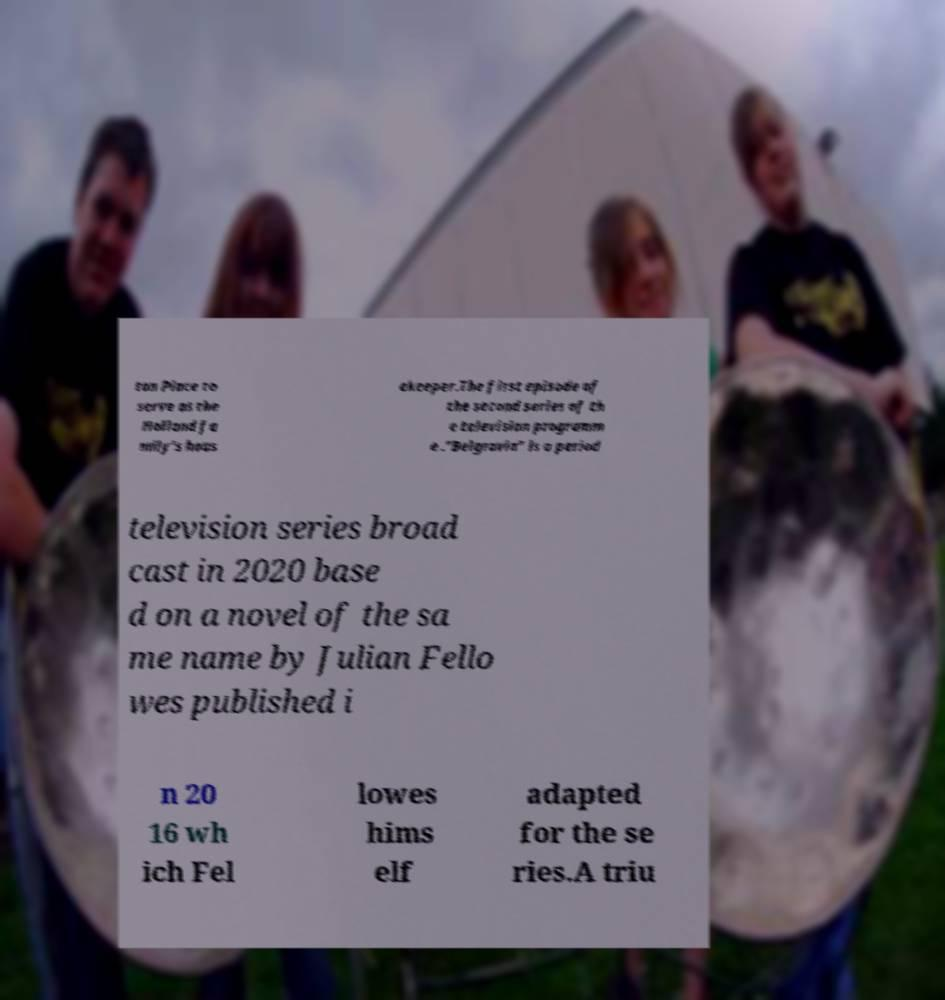Please identify and transcribe the text found in this image. ton Place to serve as the Holland fa mily's hous ekeeper.The first episode of the second series of th e television programm e ."Belgravia" is a period television series broad cast in 2020 base d on a novel of the sa me name by Julian Fello wes published i n 20 16 wh ich Fel lowes hims elf adapted for the se ries.A triu 